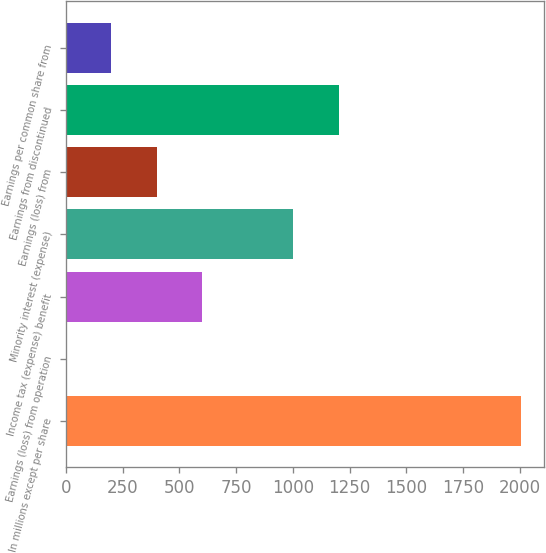Convert chart. <chart><loc_0><loc_0><loc_500><loc_500><bar_chart><fcel>In millions except per share<fcel>Earnings (loss) from operation<fcel>Income tax (expense) benefit<fcel>Minority interest (expense)<fcel>Earnings (loss) from<fcel>Earnings from discontinued<fcel>Earnings per common share from<nl><fcel>2004<fcel>0.06<fcel>601.23<fcel>1002.01<fcel>400.84<fcel>1202.4<fcel>200.45<nl></chart> 